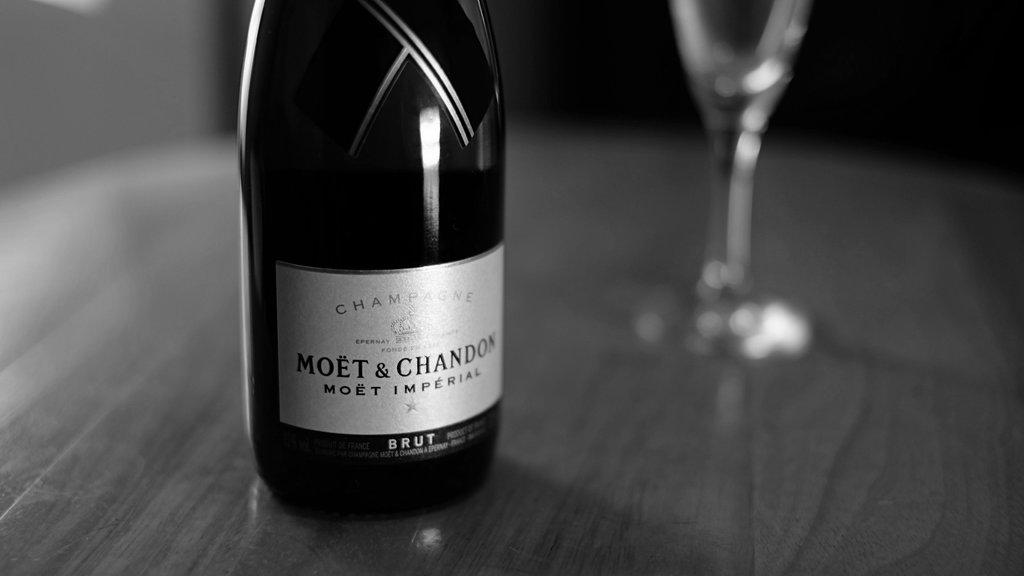What is the color scheme of the image? The image is black and white. What piece of furniture is present in the image? There is a table in the image. What items are placed on the table? A bottle and a wine glass are placed on the table. Can you describe the bottle in the image? The bottle has a white color sticker on it, and the sticker has some text on it. Can you tell me how many snails are crawling on the table in the image? There are no snails present in the image; it only features a table, a bottle, and a wine glass. What message of love can be seen on the sticker in the image? There is no message of love on the sticker in the image; it only has some text, which is not specified in the provided facts. 